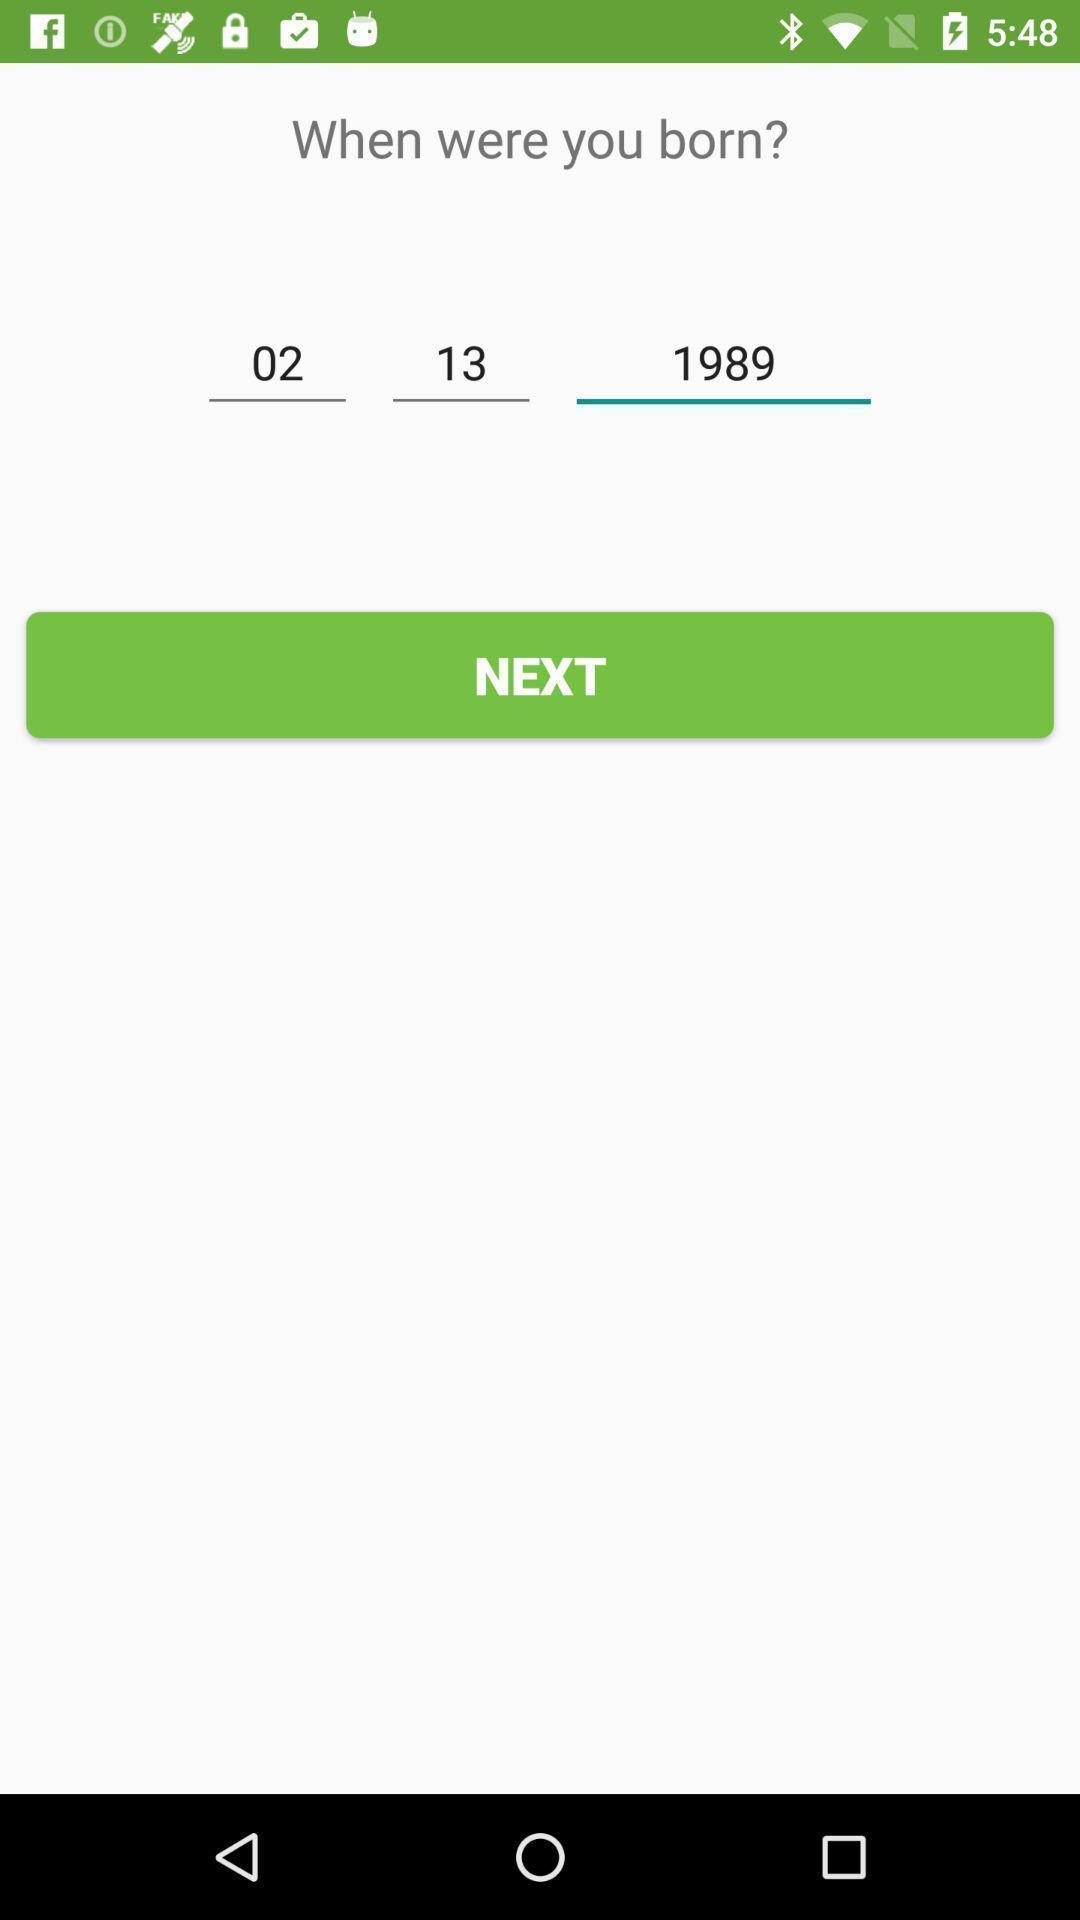Provide a detailed account of this screenshot. Screen showing the date of birth of a person. 